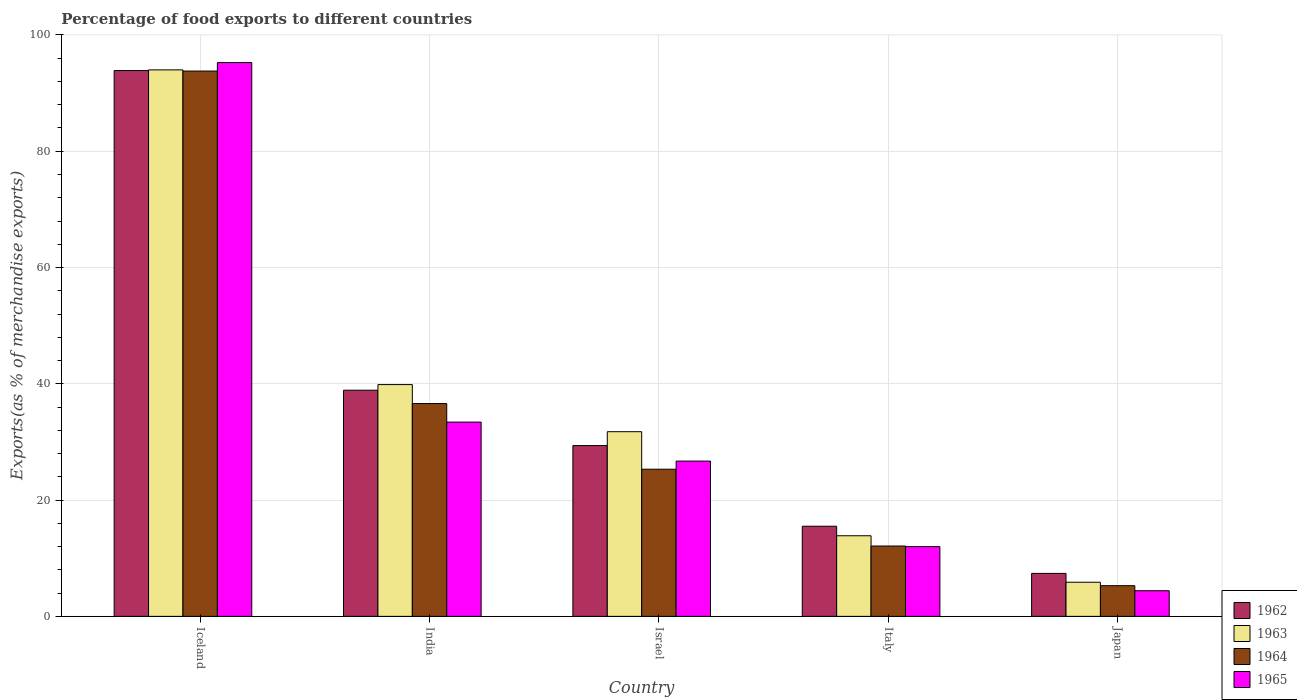How many different coloured bars are there?
Offer a terse response. 4. Are the number of bars per tick equal to the number of legend labels?
Keep it short and to the point. Yes. Are the number of bars on each tick of the X-axis equal?
Your answer should be very brief. Yes. How many bars are there on the 2nd tick from the left?
Your answer should be very brief. 4. How many bars are there on the 3rd tick from the right?
Your answer should be compact. 4. In how many cases, is the number of bars for a given country not equal to the number of legend labels?
Offer a terse response. 0. What is the percentage of exports to different countries in 1962 in India?
Offer a very short reply. 38.9. Across all countries, what is the maximum percentage of exports to different countries in 1965?
Your answer should be very brief. 95.25. Across all countries, what is the minimum percentage of exports to different countries in 1963?
Provide a succinct answer. 5.87. What is the total percentage of exports to different countries in 1963 in the graph?
Ensure brevity in your answer.  185.35. What is the difference between the percentage of exports to different countries in 1964 in Iceland and that in Israel?
Your answer should be very brief. 68.48. What is the difference between the percentage of exports to different countries in 1964 in Iceland and the percentage of exports to different countries in 1962 in Israel?
Give a very brief answer. 64.42. What is the average percentage of exports to different countries in 1962 per country?
Ensure brevity in your answer.  37.01. What is the difference between the percentage of exports to different countries of/in 1965 and percentage of exports to different countries of/in 1962 in India?
Your response must be concise. -5.48. In how many countries, is the percentage of exports to different countries in 1964 greater than 32 %?
Make the answer very short. 2. What is the ratio of the percentage of exports to different countries in 1962 in Israel to that in Japan?
Offer a terse response. 3.98. Is the percentage of exports to different countries in 1965 in India less than that in Japan?
Offer a terse response. No. What is the difference between the highest and the second highest percentage of exports to different countries in 1962?
Offer a very short reply. -64.5. What is the difference between the highest and the lowest percentage of exports to different countries in 1963?
Make the answer very short. 88.12. In how many countries, is the percentage of exports to different countries in 1963 greater than the average percentage of exports to different countries in 1963 taken over all countries?
Make the answer very short. 2. Is the sum of the percentage of exports to different countries in 1962 in Italy and Japan greater than the maximum percentage of exports to different countries in 1965 across all countries?
Offer a terse response. No. What does the 4th bar from the left in Israel represents?
Offer a very short reply. 1965. What does the 1st bar from the right in Japan represents?
Keep it short and to the point. 1965. How many bars are there?
Make the answer very short. 20. Are all the bars in the graph horizontal?
Ensure brevity in your answer.  No. What is the difference between two consecutive major ticks on the Y-axis?
Your response must be concise. 20. Are the values on the major ticks of Y-axis written in scientific E-notation?
Offer a very short reply. No. What is the title of the graph?
Your response must be concise. Percentage of food exports to different countries. Does "1992" appear as one of the legend labels in the graph?
Ensure brevity in your answer.  No. What is the label or title of the X-axis?
Provide a short and direct response. Country. What is the label or title of the Y-axis?
Give a very brief answer. Exports(as % of merchandise exports). What is the Exports(as % of merchandise exports) of 1962 in Iceland?
Your answer should be very brief. 93.87. What is the Exports(as % of merchandise exports) in 1963 in Iceland?
Offer a very short reply. 93.99. What is the Exports(as % of merchandise exports) of 1964 in Iceland?
Your answer should be very brief. 93.79. What is the Exports(as % of merchandise exports) of 1965 in Iceland?
Provide a short and direct response. 95.25. What is the Exports(as % of merchandise exports) in 1962 in India?
Your answer should be very brief. 38.9. What is the Exports(as % of merchandise exports) in 1963 in India?
Offer a very short reply. 39.86. What is the Exports(as % of merchandise exports) of 1964 in India?
Provide a short and direct response. 36.6. What is the Exports(as % of merchandise exports) of 1965 in India?
Offer a terse response. 33.41. What is the Exports(as % of merchandise exports) in 1962 in Israel?
Make the answer very short. 29.37. What is the Exports(as % of merchandise exports) in 1963 in Israel?
Give a very brief answer. 31.76. What is the Exports(as % of merchandise exports) in 1964 in Israel?
Provide a succinct answer. 25.31. What is the Exports(as % of merchandise exports) of 1965 in Israel?
Provide a succinct answer. 26.71. What is the Exports(as % of merchandise exports) of 1962 in Italy?
Offer a very short reply. 15.5. What is the Exports(as % of merchandise exports) in 1963 in Italy?
Ensure brevity in your answer.  13.86. What is the Exports(as % of merchandise exports) of 1964 in Italy?
Make the answer very short. 12.1. What is the Exports(as % of merchandise exports) in 1965 in Italy?
Provide a succinct answer. 12. What is the Exports(as % of merchandise exports) of 1962 in Japan?
Your answer should be very brief. 7.39. What is the Exports(as % of merchandise exports) of 1963 in Japan?
Ensure brevity in your answer.  5.87. What is the Exports(as % of merchandise exports) in 1964 in Japan?
Your answer should be compact. 5.28. What is the Exports(as % of merchandise exports) of 1965 in Japan?
Your answer should be compact. 4.41. Across all countries, what is the maximum Exports(as % of merchandise exports) in 1962?
Keep it short and to the point. 93.87. Across all countries, what is the maximum Exports(as % of merchandise exports) in 1963?
Your response must be concise. 93.99. Across all countries, what is the maximum Exports(as % of merchandise exports) of 1964?
Offer a very short reply. 93.79. Across all countries, what is the maximum Exports(as % of merchandise exports) of 1965?
Offer a terse response. 95.25. Across all countries, what is the minimum Exports(as % of merchandise exports) in 1962?
Keep it short and to the point. 7.39. Across all countries, what is the minimum Exports(as % of merchandise exports) in 1963?
Give a very brief answer. 5.87. Across all countries, what is the minimum Exports(as % of merchandise exports) of 1964?
Offer a terse response. 5.28. Across all countries, what is the minimum Exports(as % of merchandise exports) in 1965?
Keep it short and to the point. 4.41. What is the total Exports(as % of merchandise exports) in 1962 in the graph?
Offer a very short reply. 185.04. What is the total Exports(as % of merchandise exports) of 1963 in the graph?
Ensure brevity in your answer.  185.35. What is the total Exports(as % of merchandise exports) of 1964 in the graph?
Your answer should be compact. 173.08. What is the total Exports(as % of merchandise exports) of 1965 in the graph?
Offer a very short reply. 171.78. What is the difference between the Exports(as % of merchandise exports) of 1962 in Iceland and that in India?
Your answer should be compact. 54.98. What is the difference between the Exports(as % of merchandise exports) in 1963 in Iceland and that in India?
Make the answer very short. 54.13. What is the difference between the Exports(as % of merchandise exports) in 1964 in Iceland and that in India?
Give a very brief answer. 57.19. What is the difference between the Exports(as % of merchandise exports) of 1965 in Iceland and that in India?
Give a very brief answer. 61.84. What is the difference between the Exports(as % of merchandise exports) in 1962 in Iceland and that in Israel?
Your response must be concise. 64.5. What is the difference between the Exports(as % of merchandise exports) of 1963 in Iceland and that in Israel?
Provide a succinct answer. 62.23. What is the difference between the Exports(as % of merchandise exports) in 1964 in Iceland and that in Israel?
Keep it short and to the point. 68.48. What is the difference between the Exports(as % of merchandise exports) of 1965 in Iceland and that in Israel?
Make the answer very short. 68.54. What is the difference between the Exports(as % of merchandise exports) of 1962 in Iceland and that in Italy?
Your answer should be very brief. 78.37. What is the difference between the Exports(as % of merchandise exports) of 1963 in Iceland and that in Italy?
Your answer should be very brief. 80.13. What is the difference between the Exports(as % of merchandise exports) of 1964 in Iceland and that in Italy?
Your response must be concise. 81.69. What is the difference between the Exports(as % of merchandise exports) in 1965 in Iceland and that in Italy?
Give a very brief answer. 83.25. What is the difference between the Exports(as % of merchandise exports) in 1962 in Iceland and that in Japan?
Give a very brief answer. 86.49. What is the difference between the Exports(as % of merchandise exports) of 1963 in Iceland and that in Japan?
Make the answer very short. 88.12. What is the difference between the Exports(as % of merchandise exports) of 1964 in Iceland and that in Japan?
Give a very brief answer. 88.51. What is the difference between the Exports(as % of merchandise exports) in 1965 in Iceland and that in Japan?
Make the answer very short. 90.84. What is the difference between the Exports(as % of merchandise exports) of 1962 in India and that in Israel?
Ensure brevity in your answer.  9.52. What is the difference between the Exports(as % of merchandise exports) of 1963 in India and that in Israel?
Keep it short and to the point. 8.1. What is the difference between the Exports(as % of merchandise exports) in 1964 in India and that in Israel?
Offer a terse response. 11.29. What is the difference between the Exports(as % of merchandise exports) in 1965 in India and that in Israel?
Your answer should be compact. 6.71. What is the difference between the Exports(as % of merchandise exports) of 1962 in India and that in Italy?
Provide a short and direct response. 23.39. What is the difference between the Exports(as % of merchandise exports) of 1963 in India and that in Italy?
Offer a terse response. 26. What is the difference between the Exports(as % of merchandise exports) of 1964 in India and that in Italy?
Provide a succinct answer. 24.5. What is the difference between the Exports(as % of merchandise exports) in 1965 in India and that in Italy?
Give a very brief answer. 21.41. What is the difference between the Exports(as % of merchandise exports) of 1962 in India and that in Japan?
Offer a terse response. 31.51. What is the difference between the Exports(as % of merchandise exports) in 1963 in India and that in Japan?
Your response must be concise. 34. What is the difference between the Exports(as % of merchandise exports) of 1964 in India and that in Japan?
Keep it short and to the point. 31.32. What is the difference between the Exports(as % of merchandise exports) of 1965 in India and that in Japan?
Make the answer very short. 29.01. What is the difference between the Exports(as % of merchandise exports) in 1962 in Israel and that in Italy?
Offer a very short reply. 13.87. What is the difference between the Exports(as % of merchandise exports) of 1963 in Israel and that in Italy?
Your answer should be very brief. 17.9. What is the difference between the Exports(as % of merchandise exports) in 1964 in Israel and that in Italy?
Give a very brief answer. 13.21. What is the difference between the Exports(as % of merchandise exports) in 1965 in Israel and that in Italy?
Ensure brevity in your answer.  14.71. What is the difference between the Exports(as % of merchandise exports) of 1962 in Israel and that in Japan?
Provide a short and direct response. 21.98. What is the difference between the Exports(as % of merchandise exports) in 1963 in Israel and that in Japan?
Offer a very short reply. 25.89. What is the difference between the Exports(as % of merchandise exports) in 1964 in Israel and that in Japan?
Your answer should be compact. 20.03. What is the difference between the Exports(as % of merchandise exports) in 1965 in Israel and that in Japan?
Make the answer very short. 22.3. What is the difference between the Exports(as % of merchandise exports) of 1962 in Italy and that in Japan?
Provide a succinct answer. 8.11. What is the difference between the Exports(as % of merchandise exports) in 1963 in Italy and that in Japan?
Offer a terse response. 8. What is the difference between the Exports(as % of merchandise exports) in 1964 in Italy and that in Japan?
Offer a terse response. 6.82. What is the difference between the Exports(as % of merchandise exports) of 1965 in Italy and that in Japan?
Your answer should be very brief. 7.59. What is the difference between the Exports(as % of merchandise exports) in 1962 in Iceland and the Exports(as % of merchandise exports) in 1963 in India?
Give a very brief answer. 54.01. What is the difference between the Exports(as % of merchandise exports) in 1962 in Iceland and the Exports(as % of merchandise exports) in 1964 in India?
Offer a terse response. 57.27. What is the difference between the Exports(as % of merchandise exports) in 1962 in Iceland and the Exports(as % of merchandise exports) in 1965 in India?
Your answer should be compact. 60.46. What is the difference between the Exports(as % of merchandise exports) in 1963 in Iceland and the Exports(as % of merchandise exports) in 1964 in India?
Keep it short and to the point. 57.39. What is the difference between the Exports(as % of merchandise exports) of 1963 in Iceland and the Exports(as % of merchandise exports) of 1965 in India?
Your answer should be compact. 60.58. What is the difference between the Exports(as % of merchandise exports) of 1964 in Iceland and the Exports(as % of merchandise exports) of 1965 in India?
Give a very brief answer. 60.38. What is the difference between the Exports(as % of merchandise exports) of 1962 in Iceland and the Exports(as % of merchandise exports) of 1963 in Israel?
Your answer should be very brief. 62.11. What is the difference between the Exports(as % of merchandise exports) of 1962 in Iceland and the Exports(as % of merchandise exports) of 1964 in Israel?
Your answer should be compact. 68.57. What is the difference between the Exports(as % of merchandise exports) in 1962 in Iceland and the Exports(as % of merchandise exports) in 1965 in Israel?
Make the answer very short. 67.17. What is the difference between the Exports(as % of merchandise exports) of 1963 in Iceland and the Exports(as % of merchandise exports) of 1964 in Israel?
Offer a very short reply. 68.68. What is the difference between the Exports(as % of merchandise exports) in 1963 in Iceland and the Exports(as % of merchandise exports) in 1965 in Israel?
Your answer should be very brief. 67.28. What is the difference between the Exports(as % of merchandise exports) of 1964 in Iceland and the Exports(as % of merchandise exports) of 1965 in Israel?
Offer a very short reply. 67.08. What is the difference between the Exports(as % of merchandise exports) in 1962 in Iceland and the Exports(as % of merchandise exports) in 1963 in Italy?
Make the answer very short. 80.01. What is the difference between the Exports(as % of merchandise exports) of 1962 in Iceland and the Exports(as % of merchandise exports) of 1964 in Italy?
Ensure brevity in your answer.  81.78. What is the difference between the Exports(as % of merchandise exports) in 1962 in Iceland and the Exports(as % of merchandise exports) in 1965 in Italy?
Make the answer very short. 81.88. What is the difference between the Exports(as % of merchandise exports) in 1963 in Iceland and the Exports(as % of merchandise exports) in 1964 in Italy?
Ensure brevity in your answer.  81.89. What is the difference between the Exports(as % of merchandise exports) of 1963 in Iceland and the Exports(as % of merchandise exports) of 1965 in Italy?
Make the answer very short. 81.99. What is the difference between the Exports(as % of merchandise exports) of 1964 in Iceland and the Exports(as % of merchandise exports) of 1965 in Italy?
Your answer should be compact. 81.79. What is the difference between the Exports(as % of merchandise exports) in 1962 in Iceland and the Exports(as % of merchandise exports) in 1963 in Japan?
Provide a succinct answer. 88.01. What is the difference between the Exports(as % of merchandise exports) of 1962 in Iceland and the Exports(as % of merchandise exports) of 1964 in Japan?
Provide a succinct answer. 88.6. What is the difference between the Exports(as % of merchandise exports) of 1962 in Iceland and the Exports(as % of merchandise exports) of 1965 in Japan?
Provide a short and direct response. 89.47. What is the difference between the Exports(as % of merchandise exports) in 1963 in Iceland and the Exports(as % of merchandise exports) in 1964 in Japan?
Give a very brief answer. 88.71. What is the difference between the Exports(as % of merchandise exports) in 1963 in Iceland and the Exports(as % of merchandise exports) in 1965 in Japan?
Your answer should be compact. 89.58. What is the difference between the Exports(as % of merchandise exports) in 1964 in Iceland and the Exports(as % of merchandise exports) in 1965 in Japan?
Make the answer very short. 89.38. What is the difference between the Exports(as % of merchandise exports) of 1962 in India and the Exports(as % of merchandise exports) of 1963 in Israel?
Make the answer very short. 7.14. What is the difference between the Exports(as % of merchandise exports) in 1962 in India and the Exports(as % of merchandise exports) in 1964 in Israel?
Provide a succinct answer. 13.59. What is the difference between the Exports(as % of merchandise exports) of 1962 in India and the Exports(as % of merchandise exports) of 1965 in Israel?
Make the answer very short. 12.19. What is the difference between the Exports(as % of merchandise exports) in 1963 in India and the Exports(as % of merchandise exports) in 1964 in Israel?
Your response must be concise. 14.56. What is the difference between the Exports(as % of merchandise exports) in 1963 in India and the Exports(as % of merchandise exports) in 1965 in Israel?
Your response must be concise. 13.16. What is the difference between the Exports(as % of merchandise exports) of 1964 in India and the Exports(as % of merchandise exports) of 1965 in Israel?
Provide a succinct answer. 9.89. What is the difference between the Exports(as % of merchandise exports) in 1962 in India and the Exports(as % of merchandise exports) in 1963 in Italy?
Give a very brief answer. 25.03. What is the difference between the Exports(as % of merchandise exports) of 1962 in India and the Exports(as % of merchandise exports) of 1964 in Italy?
Ensure brevity in your answer.  26.8. What is the difference between the Exports(as % of merchandise exports) of 1962 in India and the Exports(as % of merchandise exports) of 1965 in Italy?
Keep it short and to the point. 26.9. What is the difference between the Exports(as % of merchandise exports) in 1963 in India and the Exports(as % of merchandise exports) in 1964 in Italy?
Make the answer very short. 27.77. What is the difference between the Exports(as % of merchandise exports) in 1963 in India and the Exports(as % of merchandise exports) in 1965 in Italy?
Your response must be concise. 27.87. What is the difference between the Exports(as % of merchandise exports) in 1964 in India and the Exports(as % of merchandise exports) in 1965 in Italy?
Provide a succinct answer. 24.6. What is the difference between the Exports(as % of merchandise exports) in 1962 in India and the Exports(as % of merchandise exports) in 1963 in Japan?
Your response must be concise. 33.03. What is the difference between the Exports(as % of merchandise exports) in 1962 in India and the Exports(as % of merchandise exports) in 1964 in Japan?
Offer a very short reply. 33.62. What is the difference between the Exports(as % of merchandise exports) in 1962 in India and the Exports(as % of merchandise exports) in 1965 in Japan?
Your answer should be very brief. 34.49. What is the difference between the Exports(as % of merchandise exports) in 1963 in India and the Exports(as % of merchandise exports) in 1964 in Japan?
Offer a very short reply. 34.59. What is the difference between the Exports(as % of merchandise exports) in 1963 in India and the Exports(as % of merchandise exports) in 1965 in Japan?
Offer a very short reply. 35.46. What is the difference between the Exports(as % of merchandise exports) in 1964 in India and the Exports(as % of merchandise exports) in 1965 in Japan?
Keep it short and to the point. 32.2. What is the difference between the Exports(as % of merchandise exports) of 1962 in Israel and the Exports(as % of merchandise exports) of 1963 in Italy?
Offer a terse response. 15.51. What is the difference between the Exports(as % of merchandise exports) in 1962 in Israel and the Exports(as % of merchandise exports) in 1964 in Italy?
Keep it short and to the point. 17.27. What is the difference between the Exports(as % of merchandise exports) in 1962 in Israel and the Exports(as % of merchandise exports) in 1965 in Italy?
Offer a very short reply. 17.38. What is the difference between the Exports(as % of merchandise exports) in 1963 in Israel and the Exports(as % of merchandise exports) in 1964 in Italy?
Your response must be concise. 19.66. What is the difference between the Exports(as % of merchandise exports) of 1963 in Israel and the Exports(as % of merchandise exports) of 1965 in Italy?
Make the answer very short. 19.76. What is the difference between the Exports(as % of merchandise exports) of 1964 in Israel and the Exports(as % of merchandise exports) of 1965 in Italy?
Your answer should be very brief. 13.31. What is the difference between the Exports(as % of merchandise exports) of 1962 in Israel and the Exports(as % of merchandise exports) of 1963 in Japan?
Provide a short and direct response. 23.51. What is the difference between the Exports(as % of merchandise exports) in 1962 in Israel and the Exports(as % of merchandise exports) in 1964 in Japan?
Offer a very short reply. 24.1. What is the difference between the Exports(as % of merchandise exports) in 1962 in Israel and the Exports(as % of merchandise exports) in 1965 in Japan?
Offer a very short reply. 24.97. What is the difference between the Exports(as % of merchandise exports) in 1963 in Israel and the Exports(as % of merchandise exports) in 1964 in Japan?
Offer a terse response. 26.48. What is the difference between the Exports(as % of merchandise exports) of 1963 in Israel and the Exports(as % of merchandise exports) of 1965 in Japan?
Your answer should be compact. 27.35. What is the difference between the Exports(as % of merchandise exports) of 1964 in Israel and the Exports(as % of merchandise exports) of 1965 in Japan?
Offer a very short reply. 20.9. What is the difference between the Exports(as % of merchandise exports) in 1962 in Italy and the Exports(as % of merchandise exports) in 1963 in Japan?
Offer a terse response. 9.63. What is the difference between the Exports(as % of merchandise exports) of 1962 in Italy and the Exports(as % of merchandise exports) of 1964 in Japan?
Offer a very short reply. 10.23. What is the difference between the Exports(as % of merchandise exports) of 1962 in Italy and the Exports(as % of merchandise exports) of 1965 in Japan?
Offer a terse response. 11.1. What is the difference between the Exports(as % of merchandise exports) of 1963 in Italy and the Exports(as % of merchandise exports) of 1964 in Japan?
Provide a short and direct response. 8.59. What is the difference between the Exports(as % of merchandise exports) in 1963 in Italy and the Exports(as % of merchandise exports) in 1965 in Japan?
Provide a short and direct response. 9.46. What is the difference between the Exports(as % of merchandise exports) in 1964 in Italy and the Exports(as % of merchandise exports) in 1965 in Japan?
Your response must be concise. 7.69. What is the average Exports(as % of merchandise exports) in 1962 per country?
Provide a short and direct response. 37.01. What is the average Exports(as % of merchandise exports) of 1963 per country?
Offer a terse response. 37.07. What is the average Exports(as % of merchandise exports) of 1964 per country?
Your response must be concise. 34.62. What is the average Exports(as % of merchandise exports) in 1965 per country?
Provide a succinct answer. 34.36. What is the difference between the Exports(as % of merchandise exports) of 1962 and Exports(as % of merchandise exports) of 1963 in Iceland?
Offer a terse response. -0.12. What is the difference between the Exports(as % of merchandise exports) in 1962 and Exports(as % of merchandise exports) in 1964 in Iceland?
Offer a very short reply. 0.08. What is the difference between the Exports(as % of merchandise exports) in 1962 and Exports(as % of merchandise exports) in 1965 in Iceland?
Your answer should be very brief. -1.38. What is the difference between the Exports(as % of merchandise exports) in 1963 and Exports(as % of merchandise exports) in 1964 in Iceland?
Keep it short and to the point. 0.2. What is the difference between the Exports(as % of merchandise exports) of 1963 and Exports(as % of merchandise exports) of 1965 in Iceland?
Your response must be concise. -1.26. What is the difference between the Exports(as % of merchandise exports) of 1964 and Exports(as % of merchandise exports) of 1965 in Iceland?
Provide a succinct answer. -1.46. What is the difference between the Exports(as % of merchandise exports) in 1962 and Exports(as % of merchandise exports) in 1963 in India?
Provide a short and direct response. -0.97. What is the difference between the Exports(as % of merchandise exports) in 1962 and Exports(as % of merchandise exports) in 1964 in India?
Provide a succinct answer. 2.29. What is the difference between the Exports(as % of merchandise exports) in 1962 and Exports(as % of merchandise exports) in 1965 in India?
Ensure brevity in your answer.  5.48. What is the difference between the Exports(as % of merchandise exports) in 1963 and Exports(as % of merchandise exports) in 1964 in India?
Offer a terse response. 3.26. What is the difference between the Exports(as % of merchandise exports) of 1963 and Exports(as % of merchandise exports) of 1965 in India?
Your answer should be very brief. 6.45. What is the difference between the Exports(as % of merchandise exports) of 1964 and Exports(as % of merchandise exports) of 1965 in India?
Offer a very short reply. 3.19. What is the difference between the Exports(as % of merchandise exports) in 1962 and Exports(as % of merchandise exports) in 1963 in Israel?
Your answer should be compact. -2.39. What is the difference between the Exports(as % of merchandise exports) in 1962 and Exports(as % of merchandise exports) in 1964 in Israel?
Your answer should be very brief. 4.07. What is the difference between the Exports(as % of merchandise exports) in 1962 and Exports(as % of merchandise exports) in 1965 in Israel?
Your response must be concise. 2.67. What is the difference between the Exports(as % of merchandise exports) of 1963 and Exports(as % of merchandise exports) of 1964 in Israel?
Your answer should be very brief. 6.45. What is the difference between the Exports(as % of merchandise exports) of 1963 and Exports(as % of merchandise exports) of 1965 in Israel?
Provide a short and direct response. 5.05. What is the difference between the Exports(as % of merchandise exports) in 1964 and Exports(as % of merchandise exports) in 1965 in Israel?
Ensure brevity in your answer.  -1.4. What is the difference between the Exports(as % of merchandise exports) in 1962 and Exports(as % of merchandise exports) in 1963 in Italy?
Your response must be concise. 1.64. What is the difference between the Exports(as % of merchandise exports) of 1962 and Exports(as % of merchandise exports) of 1964 in Italy?
Ensure brevity in your answer.  3.4. What is the difference between the Exports(as % of merchandise exports) of 1962 and Exports(as % of merchandise exports) of 1965 in Italy?
Offer a terse response. 3.5. What is the difference between the Exports(as % of merchandise exports) in 1963 and Exports(as % of merchandise exports) in 1964 in Italy?
Offer a terse response. 1.77. What is the difference between the Exports(as % of merchandise exports) of 1963 and Exports(as % of merchandise exports) of 1965 in Italy?
Your answer should be compact. 1.87. What is the difference between the Exports(as % of merchandise exports) in 1964 and Exports(as % of merchandise exports) in 1965 in Italy?
Provide a succinct answer. 0.1. What is the difference between the Exports(as % of merchandise exports) in 1962 and Exports(as % of merchandise exports) in 1963 in Japan?
Provide a short and direct response. 1.52. What is the difference between the Exports(as % of merchandise exports) in 1962 and Exports(as % of merchandise exports) in 1964 in Japan?
Make the answer very short. 2.11. What is the difference between the Exports(as % of merchandise exports) in 1962 and Exports(as % of merchandise exports) in 1965 in Japan?
Offer a terse response. 2.98. What is the difference between the Exports(as % of merchandise exports) of 1963 and Exports(as % of merchandise exports) of 1964 in Japan?
Your answer should be very brief. 0.59. What is the difference between the Exports(as % of merchandise exports) in 1963 and Exports(as % of merchandise exports) in 1965 in Japan?
Your answer should be compact. 1.46. What is the difference between the Exports(as % of merchandise exports) in 1964 and Exports(as % of merchandise exports) in 1965 in Japan?
Your response must be concise. 0.87. What is the ratio of the Exports(as % of merchandise exports) in 1962 in Iceland to that in India?
Provide a succinct answer. 2.41. What is the ratio of the Exports(as % of merchandise exports) of 1963 in Iceland to that in India?
Make the answer very short. 2.36. What is the ratio of the Exports(as % of merchandise exports) in 1964 in Iceland to that in India?
Offer a terse response. 2.56. What is the ratio of the Exports(as % of merchandise exports) in 1965 in Iceland to that in India?
Keep it short and to the point. 2.85. What is the ratio of the Exports(as % of merchandise exports) in 1962 in Iceland to that in Israel?
Provide a short and direct response. 3.2. What is the ratio of the Exports(as % of merchandise exports) in 1963 in Iceland to that in Israel?
Provide a succinct answer. 2.96. What is the ratio of the Exports(as % of merchandise exports) in 1964 in Iceland to that in Israel?
Provide a short and direct response. 3.71. What is the ratio of the Exports(as % of merchandise exports) in 1965 in Iceland to that in Israel?
Your response must be concise. 3.57. What is the ratio of the Exports(as % of merchandise exports) of 1962 in Iceland to that in Italy?
Provide a short and direct response. 6.05. What is the ratio of the Exports(as % of merchandise exports) of 1963 in Iceland to that in Italy?
Your response must be concise. 6.78. What is the ratio of the Exports(as % of merchandise exports) of 1964 in Iceland to that in Italy?
Your response must be concise. 7.75. What is the ratio of the Exports(as % of merchandise exports) in 1965 in Iceland to that in Italy?
Your answer should be very brief. 7.94. What is the ratio of the Exports(as % of merchandise exports) in 1962 in Iceland to that in Japan?
Your response must be concise. 12.7. What is the ratio of the Exports(as % of merchandise exports) of 1963 in Iceland to that in Japan?
Offer a terse response. 16.01. What is the ratio of the Exports(as % of merchandise exports) of 1964 in Iceland to that in Japan?
Ensure brevity in your answer.  17.77. What is the ratio of the Exports(as % of merchandise exports) of 1965 in Iceland to that in Japan?
Your answer should be compact. 21.62. What is the ratio of the Exports(as % of merchandise exports) in 1962 in India to that in Israel?
Provide a succinct answer. 1.32. What is the ratio of the Exports(as % of merchandise exports) of 1963 in India to that in Israel?
Your answer should be very brief. 1.26. What is the ratio of the Exports(as % of merchandise exports) in 1964 in India to that in Israel?
Offer a terse response. 1.45. What is the ratio of the Exports(as % of merchandise exports) of 1965 in India to that in Israel?
Your answer should be very brief. 1.25. What is the ratio of the Exports(as % of merchandise exports) of 1962 in India to that in Italy?
Ensure brevity in your answer.  2.51. What is the ratio of the Exports(as % of merchandise exports) in 1963 in India to that in Italy?
Your answer should be compact. 2.88. What is the ratio of the Exports(as % of merchandise exports) of 1964 in India to that in Italy?
Make the answer very short. 3.03. What is the ratio of the Exports(as % of merchandise exports) of 1965 in India to that in Italy?
Offer a terse response. 2.78. What is the ratio of the Exports(as % of merchandise exports) in 1962 in India to that in Japan?
Make the answer very short. 5.26. What is the ratio of the Exports(as % of merchandise exports) in 1963 in India to that in Japan?
Provide a short and direct response. 6.79. What is the ratio of the Exports(as % of merchandise exports) in 1964 in India to that in Japan?
Offer a very short reply. 6.93. What is the ratio of the Exports(as % of merchandise exports) of 1965 in India to that in Japan?
Provide a short and direct response. 7.58. What is the ratio of the Exports(as % of merchandise exports) in 1962 in Israel to that in Italy?
Provide a short and direct response. 1.89. What is the ratio of the Exports(as % of merchandise exports) of 1963 in Israel to that in Italy?
Ensure brevity in your answer.  2.29. What is the ratio of the Exports(as % of merchandise exports) of 1964 in Israel to that in Italy?
Your response must be concise. 2.09. What is the ratio of the Exports(as % of merchandise exports) in 1965 in Israel to that in Italy?
Your answer should be very brief. 2.23. What is the ratio of the Exports(as % of merchandise exports) in 1962 in Israel to that in Japan?
Your answer should be very brief. 3.98. What is the ratio of the Exports(as % of merchandise exports) in 1963 in Israel to that in Japan?
Ensure brevity in your answer.  5.41. What is the ratio of the Exports(as % of merchandise exports) in 1964 in Israel to that in Japan?
Offer a very short reply. 4.79. What is the ratio of the Exports(as % of merchandise exports) in 1965 in Israel to that in Japan?
Ensure brevity in your answer.  6.06. What is the ratio of the Exports(as % of merchandise exports) of 1962 in Italy to that in Japan?
Provide a succinct answer. 2.1. What is the ratio of the Exports(as % of merchandise exports) of 1963 in Italy to that in Japan?
Offer a very short reply. 2.36. What is the ratio of the Exports(as % of merchandise exports) of 1964 in Italy to that in Japan?
Your answer should be very brief. 2.29. What is the ratio of the Exports(as % of merchandise exports) in 1965 in Italy to that in Japan?
Offer a very short reply. 2.72. What is the difference between the highest and the second highest Exports(as % of merchandise exports) in 1962?
Keep it short and to the point. 54.98. What is the difference between the highest and the second highest Exports(as % of merchandise exports) of 1963?
Provide a short and direct response. 54.13. What is the difference between the highest and the second highest Exports(as % of merchandise exports) in 1964?
Offer a very short reply. 57.19. What is the difference between the highest and the second highest Exports(as % of merchandise exports) in 1965?
Give a very brief answer. 61.84. What is the difference between the highest and the lowest Exports(as % of merchandise exports) in 1962?
Your answer should be compact. 86.49. What is the difference between the highest and the lowest Exports(as % of merchandise exports) of 1963?
Ensure brevity in your answer.  88.12. What is the difference between the highest and the lowest Exports(as % of merchandise exports) of 1964?
Offer a very short reply. 88.51. What is the difference between the highest and the lowest Exports(as % of merchandise exports) in 1965?
Offer a very short reply. 90.84. 